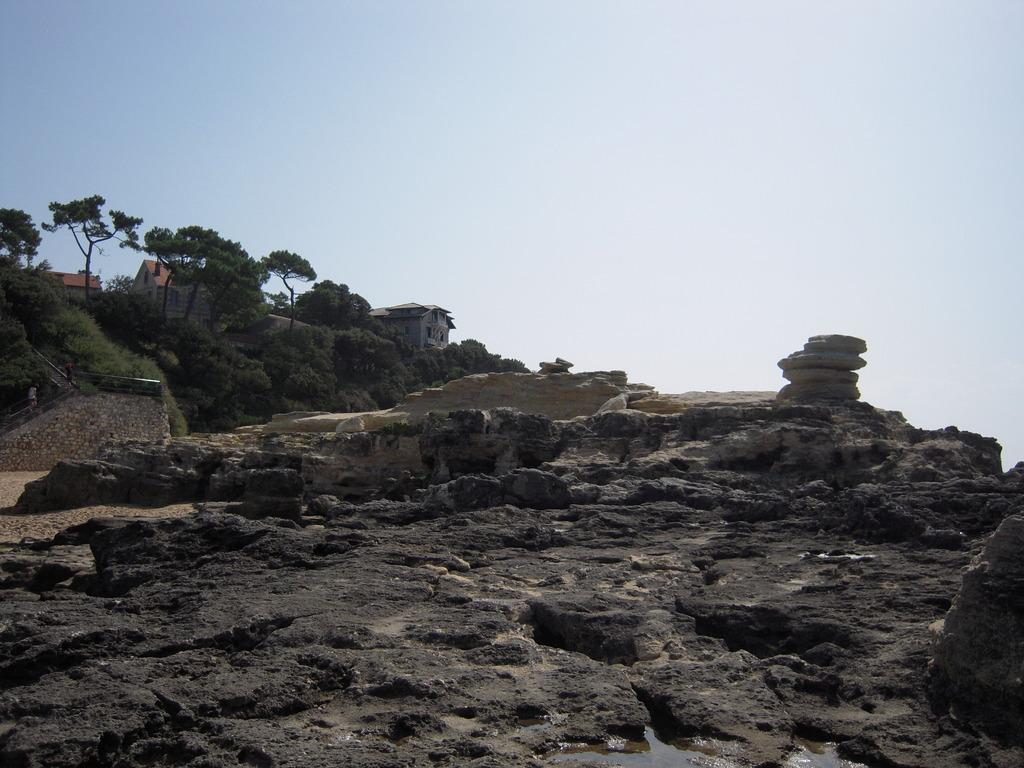What is located in the front of the image? There is water in the front of the image. What can be seen in the center of the image? There are stones in the center of the image. What type of vegetation is visible in the background of the image? There are trees in the background of the image. What type of structures can be seen in the background of the image? There are houses in the background of the image. What type of net is being used to catch fish in the image? There is no net present in the image; it features water, stones, trees, and houses. What type of company is depicted in the image? There is no company depicted in the image; it features natural elements and structures. 